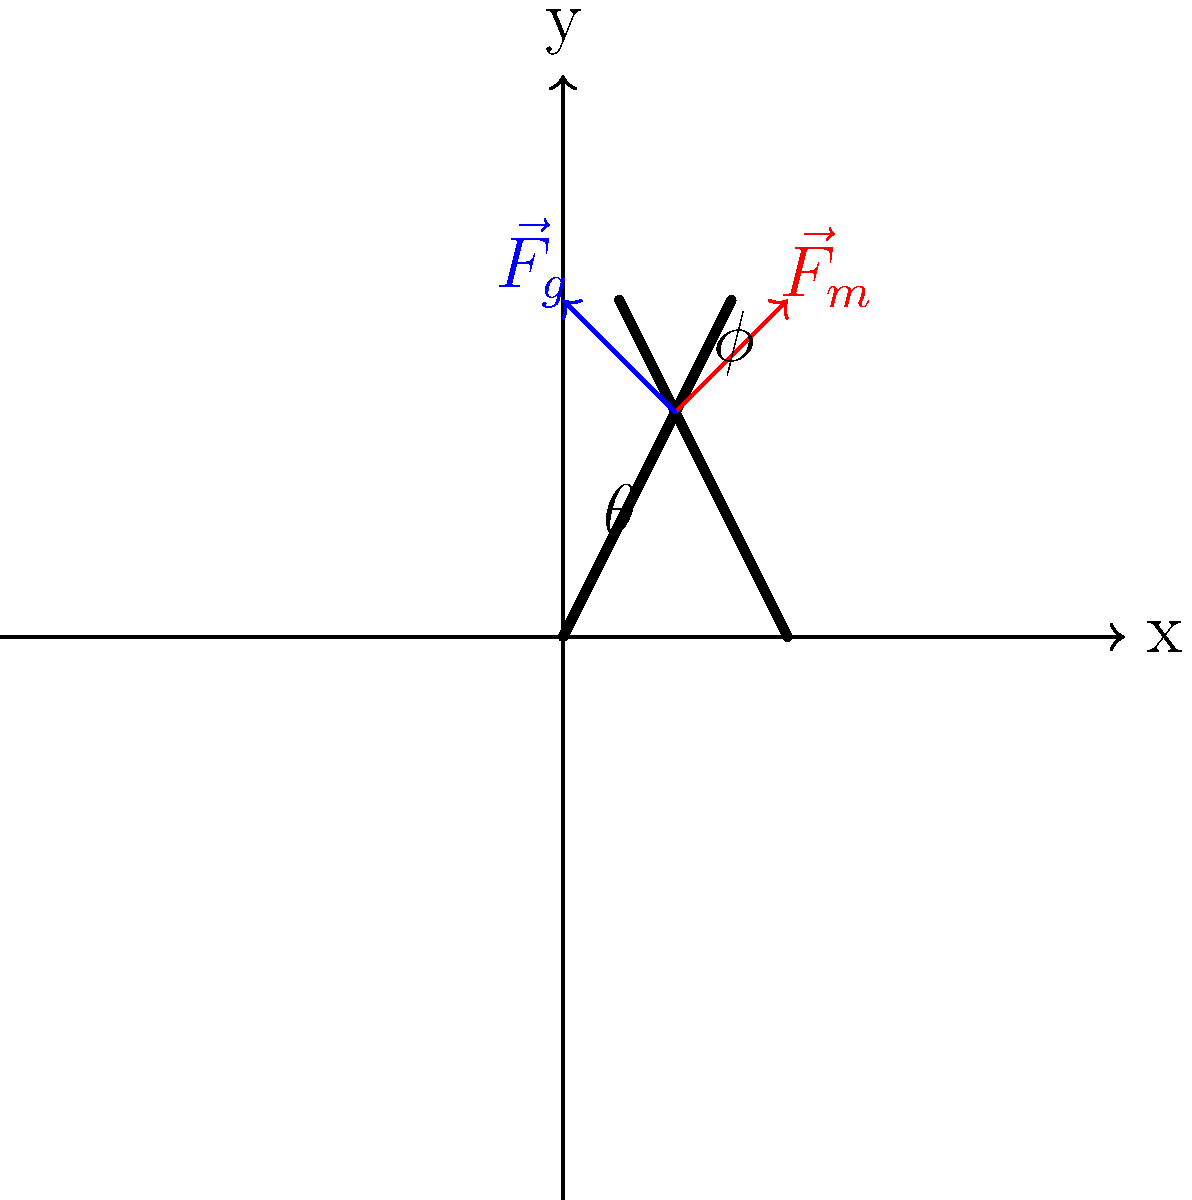In the Aztec ball game, players often needed to strike the ball with their hips. Consider the diagram showing a player's body position at the moment of impact. If the angle $\theta$ between the player's torso and legs is 120°, and the angle $\phi$ between the player's upper arm and torso is 45°, calculate the magnitude of the muscular force $\vec{F}_m$ required to overcome gravity $\vec{F}_g$ and maintain this position. Assume the player's mass is 70 kg and $g = 9.8$ m/s². To solve this problem, we'll follow these steps:

1) First, we need to determine the gravitational force $\vec{F}_g$ acting on the player:
   $$F_g = mg = 70 \text{ kg} \times 9.8 \text{ m/s²} = 686 \text{ N}$$

2) The muscular force $\vec{F}_m$ must balance the vertical component of $\vec{F}_g$ to maintain the position. We can use trigonometry to find this:

3) The angle between $\vec{F}_g$ and the player's torso is $(180° - 120°) / 2 = 30°$. This is because the torso bisects the angle between the vertical and the legs.

4) The vertical component of $\vec{F}_g$ that needs to be balanced is:
   $$F_g \sin(30°) = 686 \text{ N} \times 0.5 = 343 \text{ N}$$

5) Now, we need to find the angle between $\vec{F}_m$ and the vertical. This is $45° + 30° = 75°$, as $\vec{F}_m$ is perpendicular to the upper arm.

6) The magnitude of $\vec{F}_m$ can be found using:
   $$F_m \sin(75°) = 343 \text{ N}$$
   $$F_m = \frac{343 \text{ N}}{\sin(75°)} \approx 355 \text{ N}$$

Therefore, the player needs to exert a muscular force of approximately 355 N to maintain this position.
Answer: 355 N 